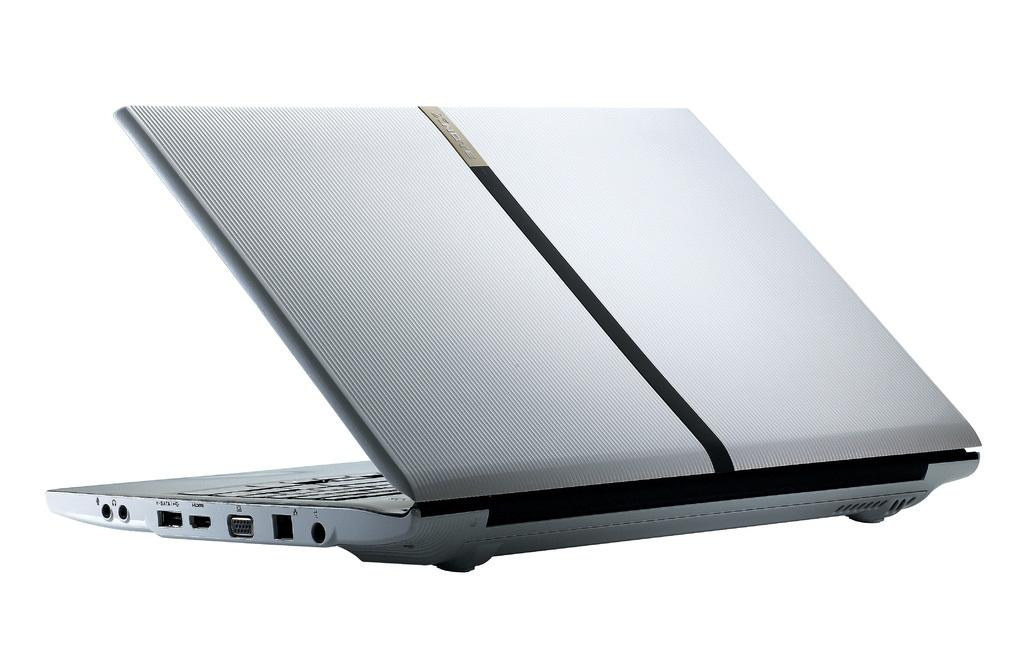What electronic device is visible in the image? There is a laptop in the image. What color is the laptop? The laptop is silver in color. What is the color of the background in the image? The background of the image is white. Where is the basin located in the image? There is no basin present in the image. What type of yam is being used as a prop in the image? There is no yam present in the image. 